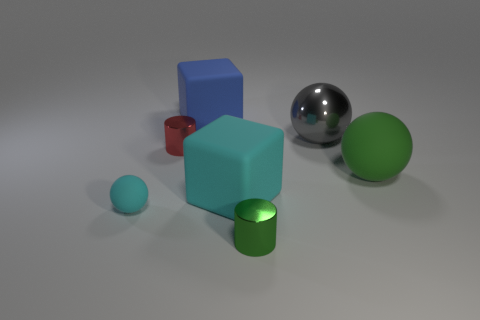There is a cube that is the same color as the small matte ball; what is it made of?
Offer a terse response. Rubber. There is a large thing that is to the left of the small green metallic cylinder and behind the large green rubber ball; what color is it?
Give a very brief answer. Blue. Are there any tiny cylinders of the same color as the big matte ball?
Your answer should be compact. Yes. There is a small cylinder that is right of the blue object; what color is it?
Keep it short and to the point. Green. Is there a object behind the rubber object that is right of the tiny green shiny cylinder?
Your answer should be compact. Yes. There is a big matte ball; is it the same color as the small metal cylinder that is in front of the tiny cyan thing?
Keep it short and to the point. Yes. Is there a big sphere that has the same material as the green cylinder?
Give a very brief answer. Yes. What number of large purple cylinders are there?
Provide a succinct answer. 0. What is the material of the cylinder that is behind the tiny object that is on the right side of the tiny red cylinder?
Offer a terse response. Metal. The other sphere that is the same material as the cyan sphere is what color?
Your response must be concise. Green. 